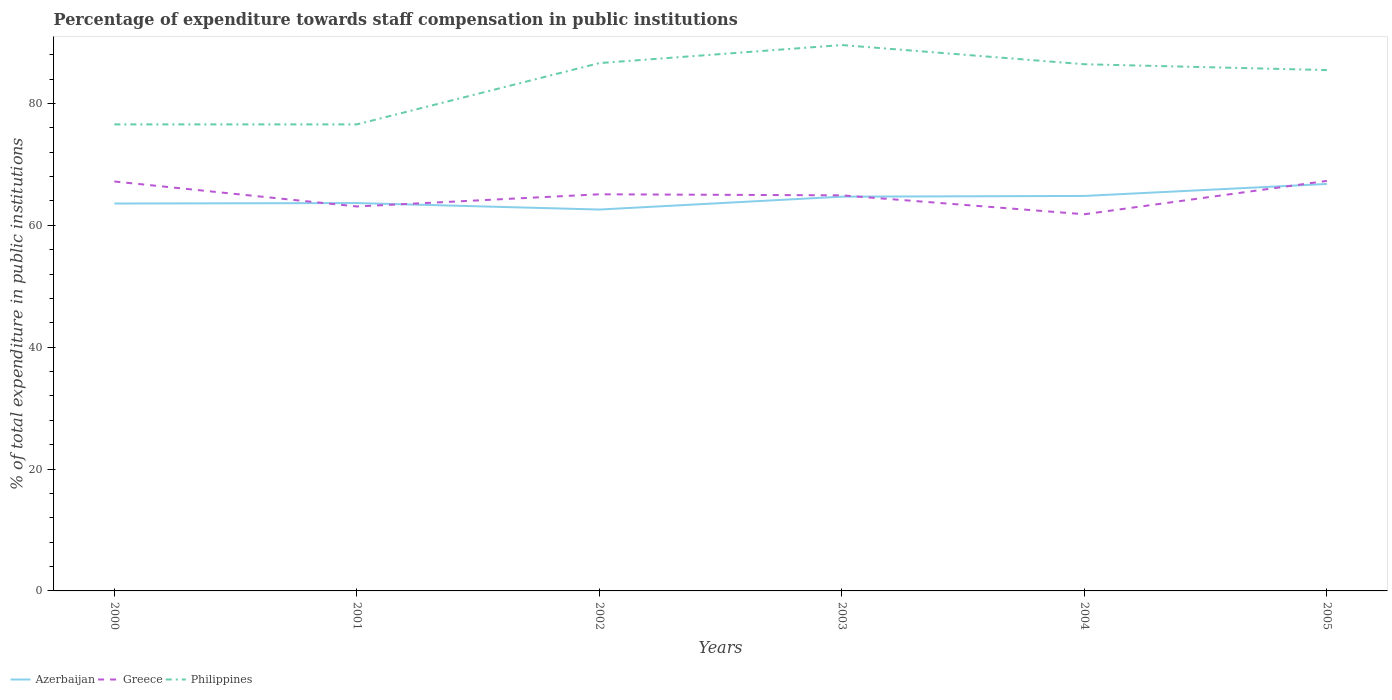Does the line corresponding to Azerbaijan intersect with the line corresponding to Philippines?
Your answer should be compact. No. Is the number of lines equal to the number of legend labels?
Your answer should be compact. Yes. Across all years, what is the maximum percentage of expenditure towards staff compensation in Greece?
Provide a short and direct response. 61.82. In which year was the percentage of expenditure towards staff compensation in Greece maximum?
Keep it short and to the point. 2004. What is the total percentage of expenditure towards staff compensation in Philippines in the graph?
Your answer should be compact. 1.14. What is the difference between the highest and the second highest percentage of expenditure towards staff compensation in Greece?
Keep it short and to the point. 5.48. Is the percentage of expenditure towards staff compensation in Greece strictly greater than the percentage of expenditure towards staff compensation in Azerbaijan over the years?
Your answer should be compact. No. How many lines are there?
Make the answer very short. 3. How many years are there in the graph?
Your answer should be very brief. 6. What is the difference between two consecutive major ticks on the Y-axis?
Provide a succinct answer. 20. Are the values on the major ticks of Y-axis written in scientific E-notation?
Make the answer very short. No. Does the graph contain grids?
Your answer should be compact. No. What is the title of the graph?
Provide a succinct answer. Percentage of expenditure towards staff compensation in public institutions. What is the label or title of the Y-axis?
Ensure brevity in your answer.  % of total expenditure in public institutions. What is the % of total expenditure in public institutions of Azerbaijan in 2000?
Your response must be concise. 63.58. What is the % of total expenditure in public institutions in Greece in 2000?
Give a very brief answer. 67.2. What is the % of total expenditure in public institutions in Philippines in 2000?
Your answer should be compact. 76.57. What is the % of total expenditure in public institutions of Azerbaijan in 2001?
Provide a short and direct response. 63.66. What is the % of total expenditure in public institutions in Greece in 2001?
Provide a succinct answer. 63.1. What is the % of total expenditure in public institutions of Philippines in 2001?
Offer a very short reply. 76.57. What is the % of total expenditure in public institutions of Azerbaijan in 2002?
Your response must be concise. 62.59. What is the % of total expenditure in public institutions of Greece in 2002?
Ensure brevity in your answer.  65.1. What is the % of total expenditure in public institutions of Philippines in 2002?
Your answer should be compact. 86.63. What is the % of total expenditure in public institutions of Azerbaijan in 2003?
Offer a terse response. 64.71. What is the % of total expenditure in public institutions in Greece in 2003?
Make the answer very short. 64.93. What is the % of total expenditure in public institutions in Philippines in 2003?
Offer a terse response. 89.59. What is the % of total expenditure in public institutions in Azerbaijan in 2004?
Provide a succinct answer. 64.83. What is the % of total expenditure in public institutions of Greece in 2004?
Provide a succinct answer. 61.82. What is the % of total expenditure in public institutions in Philippines in 2004?
Provide a short and direct response. 86.44. What is the % of total expenditure in public institutions in Azerbaijan in 2005?
Offer a very short reply. 66.79. What is the % of total expenditure in public institutions of Greece in 2005?
Offer a very short reply. 67.29. What is the % of total expenditure in public institutions of Philippines in 2005?
Your response must be concise. 85.49. Across all years, what is the maximum % of total expenditure in public institutions of Azerbaijan?
Provide a succinct answer. 66.79. Across all years, what is the maximum % of total expenditure in public institutions in Greece?
Offer a terse response. 67.29. Across all years, what is the maximum % of total expenditure in public institutions in Philippines?
Offer a very short reply. 89.59. Across all years, what is the minimum % of total expenditure in public institutions of Azerbaijan?
Your response must be concise. 62.59. Across all years, what is the minimum % of total expenditure in public institutions of Greece?
Ensure brevity in your answer.  61.82. Across all years, what is the minimum % of total expenditure in public institutions in Philippines?
Your answer should be compact. 76.57. What is the total % of total expenditure in public institutions of Azerbaijan in the graph?
Keep it short and to the point. 386.15. What is the total % of total expenditure in public institutions of Greece in the graph?
Provide a short and direct response. 389.43. What is the total % of total expenditure in public institutions in Philippines in the graph?
Offer a very short reply. 501.29. What is the difference between the % of total expenditure in public institutions in Azerbaijan in 2000 and that in 2001?
Your answer should be compact. -0.08. What is the difference between the % of total expenditure in public institutions in Greece in 2000 and that in 2001?
Make the answer very short. 4.1. What is the difference between the % of total expenditure in public institutions in Philippines in 2000 and that in 2001?
Offer a terse response. 0. What is the difference between the % of total expenditure in public institutions in Azerbaijan in 2000 and that in 2002?
Give a very brief answer. 0.99. What is the difference between the % of total expenditure in public institutions in Greece in 2000 and that in 2002?
Offer a very short reply. 2.1. What is the difference between the % of total expenditure in public institutions in Philippines in 2000 and that in 2002?
Your answer should be compact. -10.06. What is the difference between the % of total expenditure in public institutions in Azerbaijan in 2000 and that in 2003?
Provide a succinct answer. -1.13. What is the difference between the % of total expenditure in public institutions in Greece in 2000 and that in 2003?
Provide a succinct answer. 2.27. What is the difference between the % of total expenditure in public institutions of Philippines in 2000 and that in 2003?
Provide a short and direct response. -13.02. What is the difference between the % of total expenditure in public institutions in Azerbaijan in 2000 and that in 2004?
Make the answer very short. -1.24. What is the difference between the % of total expenditure in public institutions in Greece in 2000 and that in 2004?
Provide a succinct answer. 5.38. What is the difference between the % of total expenditure in public institutions in Philippines in 2000 and that in 2004?
Provide a short and direct response. -9.87. What is the difference between the % of total expenditure in public institutions in Azerbaijan in 2000 and that in 2005?
Your answer should be very brief. -3.21. What is the difference between the % of total expenditure in public institutions in Greece in 2000 and that in 2005?
Offer a terse response. -0.1. What is the difference between the % of total expenditure in public institutions in Philippines in 2000 and that in 2005?
Your response must be concise. -8.92. What is the difference between the % of total expenditure in public institutions of Azerbaijan in 2001 and that in 2002?
Make the answer very short. 1.06. What is the difference between the % of total expenditure in public institutions in Greece in 2001 and that in 2002?
Your answer should be very brief. -2. What is the difference between the % of total expenditure in public institutions in Philippines in 2001 and that in 2002?
Make the answer very short. -10.06. What is the difference between the % of total expenditure in public institutions in Azerbaijan in 2001 and that in 2003?
Offer a terse response. -1.05. What is the difference between the % of total expenditure in public institutions in Greece in 2001 and that in 2003?
Your answer should be very brief. -1.83. What is the difference between the % of total expenditure in public institutions of Philippines in 2001 and that in 2003?
Your response must be concise. -13.02. What is the difference between the % of total expenditure in public institutions of Azerbaijan in 2001 and that in 2004?
Provide a succinct answer. -1.17. What is the difference between the % of total expenditure in public institutions of Greece in 2001 and that in 2004?
Give a very brief answer. 1.28. What is the difference between the % of total expenditure in public institutions in Philippines in 2001 and that in 2004?
Your response must be concise. -9.87. What is the difference between the % of total expenditure in public institutions in Azerbaijan in 2001 and that in 2005?
Give a very brief answer. -3.13. What is the difference between the % of total expenditure in public institutions in Greece in 2001 and that in 2005?
Your answer should be compact. -4.2. What is the difference between the % of total expenditure in public institutions in Philippines in 2001 and that in 2005?
Your answer should be very brief. -8.92. What is the difference between the % of total expenditure in public institutions of Azerbaijan in 2002 and that in 2003?
Offer a terse response. -2.12. What is the difference between the % of total expenditure in public institutions of Greece in 2002 and that in 2003?
Ensure brevity in your answer.  0.17. What is the difference between the % of total expenditure in public institutions of Philippines in 2002 and that in 2003?
Provide a succinct answer. -2.96. What is the difference between the % of total expenditure in public institutions in Azerbaijan in 2002 and that in 2004?
Keep it short and to the point. -2.23. What is the difference between the % of total expenditure in public institutions in Greece in 2002 and that in 2004?
Keep it short and to the point. 3.28. What is the difference between the % of total expenditure in public institutions of Philippines in 2002 and that in 2004?
Your answer should be compact. 0.19. What is the difference between the % of total expenditure in public institutions in Azerbaijan in 2002 and that in 2005?
Your response must be concise. -4.2. What is the difference between the % of total expenditure in public institutions of Greece in 2002 and that in 2005?
Provide a succinct answer. -2.2. What is the difference between the % of total expenditure in public institutions in Philippines in 2002 and that in 2005?
Keep it short and to the point. 1.14. What is the difference between the % of total expenditure in public institutions of Azerbaijan in 2003 and that in 2004?
Offer a terse response. -0.12. What is the difference between the % of total expenditure in public institutions of Greece in 2003 and that in 2004?
Offer a terse response. 3.11. What is the difference between the % of total expenditure in public institutions in Philippines in 2003 and that in 2004?
Make the answer very short. 3.15. What is the difference between the % of total expenditure in public institutions of Azerbaijan in 2003 and that in 2005?
Your response must be concise. -2.08. What is the difference between the % of total expenditure in public institutions of Greece in 2003 and that in 2005?
Keep it short and to the point. -2.37. What is the difference between the % of total expenditure in public institutions in Philippines in 2003 and that in 2005?
Offer a terse response. 4.11. What is the difference between the % of total expenditure in public institutions of Azerbaijan in 2004 and that in 2005?
Your answer should be very brief. -1.97. What is the difference between the % of total expenditure in public institutions in Greece in 2004 and that in 2005?
Keep it short and to the point. -5.47. What is the difference between the % of total expenditure in public institutions of Philippines in 2004 and that in 2005?
Make the answer very short. 0.96. What is the difference between the % of total expenditure in public institutions in Azerbaijan in 2000 and the % of total expenditure in public institutions in Greece in 2001?
Your answer should be very brief. 0.48. What is the difference between the % of total expenditure in public institutions in Azerbaijan in 2000 and the % of total expenditure in public institutions in Philippines in 2001?
Your response must be concise. -12.99. What is the difference between the % of total expenditure in public institutions of Greece in 2000 and the % of total expenditure in public institutions of Philippines in 2001?
Offer a very short reply. -9.37. What is the difference between the % of total expenditure in public institutions in Azerbaijan in 2000 and the % of total expenditure in public institutions in Greece in 2002?
Your response must be concise. -1.51. What is the difference between the % of total expenditure in public institutions in Azerbaijan in 2000 and the % of total expenditure in public institutions in Philippines in 2002?
Keep it short and to the point. -23.05. What is the difference between the % of total expenditure in public institutions of Greece in 2000 and the % of total expenditure in public institutions of Philippines in 2002?
Your answer should be compact. -19.43. What is the difference between the % of total expenditure in public institutions in Azerbaijan in 2000 and the % of total expenditure in public institutions in Greece in 2003?
Make the answer very short. -1.34. What is the difference between the % of total expenditure in public institutions in Azerbaijan in 2000 and the % of total expenditure in public institutions in Philippines in 2003?
Your response must be concise. -26.01. What is the difference between the % of total expenditure in public institutions of Greece in 2000 and the % of total expenditure in public institutions of Philippines in 2003?
Offer a terse response. -22.39. What is the difference between the % of total expenditure in public institutions of Azerbaijan in 2000 and the % of total expenditure in public institutions of Greece in 2004?
Offer a very short reply. 1.76. What is the difference between the % of total expenditure in public institutions of Azerbaijan in 2000 and the % of total expenditure in public institutions of Philippines in 2004?
Offer a terse response. -22.86. What is the difference between the % of total expenditure in public institutions in Greece in 2000 and the % of total expenditure in public institutions in Philippines in 2004?
Make the answer very short. -19.24. What is the difference between the % of total expenditure in public institutions of Azerbaijan in 2000 and the % of total expenditure in public institutions of Greece in 2005?
Ensure brevity in your answer.  -3.71. What is the difference between the % of total expenditure in public institutions in Azerbaijan in 2000 and the % of total expenditure in public institutions in Philippines in 2005?
Offer a very short reply. -21.9. What is the difference between the % of total expenditure in public institutions in Greece in 2000 and the % of total expenditure in public institutions in Philippines in 2005?
Your answer should be compact. -18.29. What is the difference between the % of total expenditure in public institutions of Azerbaijan in 2001 and the % of total expenditure in public institutions of Greece in 2002?
Your answer should be very brief. -1.44. What is the difference between the % of total expenditure in public institutions of Azerbaijan in 2001 and the % of total expenditure in public institutions of Philippines in 2002?
Ensure brevity in your answer.  -22.97. What is the difference between the % of total expenditure in public institutions in Greece in 2001 and the % of total expenditure in public institutions in Philippines in 2002?
Make the answer very short. -23.53. What is the difference between the % of total expenditure in public institutions in Azerbaijan in 2001 and the % of total expenditure in public institutions in Greece in 2003?
Provide a short and direct response. -1.27. What is the difference between the % of total expenditure in public institutions of Azerbaijan in 2001 and the % of total expenditure in public institutions of Philippines in 2003?
Your response must be concise. -25.94. What is the difference between the % of total expenditure in public institutions in Greece in 2001 and the % of total expenditure in public institutions in Philippines in 2003?
Offer a very short reply. -26.49. What is the difference between the % of total expenditure in public institutions in Azerbaijan in 2001 and the % of total expenditure in public institutions in Greece in 2004?
Keep it short and to the point. 1.84. What is the difference between the % of total expenditure in public institutions of Azerbaijan in 2001 and the % of total expenditure in public institutions of Philippines in 2004?
Your answer should be compact. -22.78. What is the difference between the % of total expenditure in public institutions in Greece in 2001 and the % of total expenditure in public institutions in Philippines in 2004?
Provide a succinct answer. -23.34. What is the difference between the % of total expenditure in public institutions of Azerbaijan in 2001 and the % of total expenditure in public institutions of Greece in 2005?
Keep it short and to the point. -3.64. What is the difference between the % of total expenditure in public institutions in Azerbaijan in 2001 and the % of total expenditure in public institutions in Philippines in 2005?
Make the answer very short. -21.83. What is the difference between the % of total expenditure in public institutions of Greece in 2001 and the % of total expenditure in public institutions of Philippines in 2005?
Make the answer very short. -22.39. What is the difference between the % of total expenditure in public institutions of Azerbaijan in 2002 and the % of total expenditure in public institutions of Greece in 2003?
Offer a terse response. -2.33. What is the difference between the % of total expenditure in public institutions in Azerbaijan in 2002 and the % of total expenditure in public institutions in Philippines in 2003?
Offer a very short reply. -27. What is the difference between the % of total expenditure in public institutions of Greece in 2002 and the % of total expenditure in public institutions of Philippines in 2003?
Your answer should be compact. -24.5. What is the difference between the % of total expenditure in public institutions of Azerbaijan in 2002 and the % of total expenditure in public institutions of Greece in 2004?
Keep it short and to the point. 0.77. What is the difference between the % of total expenditure in public institutions in Azerbaijan in 2002 and the % of total expenditure in public institutions in Philippines in 2004?
Provide a succinct answer. -23.85. What is the difference between the % of total expenditure in public institutions in Greece in 2002 and the % of total expenditure in public institutions in Philippines in 2004?
Keep it short and to the point. -21.34. What is the difference between the % of total expenditure in public institutions in Azerbaijan in 2002 and the % of total expenditure in public institutions in Greece in 2005?
Your response must be concise. -4.7. What is the difference between the % of total expenditure in public institutions in Azerbaijan in 2002 and the % of total expenditure in public institutions in Philippines in 2005?
Your answer should be very brief. -22.89. What is the difference between the % of total expenditure in public institutions of Greece in 2002 and the % of total expenditure in public institutions of Philippines in 2005?
Your answer should be very brief. -20.39. What is the difference between the % of total expenditure in public institutions in Azerbaijan in 2003 and the % of total expenditure in public institutions in Greece in 2004?
Give a very brief answer. 2.89. What is the difference between the % of total expenditure in public institutions of Azerbaijan in 2003 and the % of total expenditure in public institutions of Philippines in 2004?
Keep it short and to the point. -21.73. What is the difference between the % of total expenditure in public institutions of Greece in 2003 and the % of total expenditure in public institutions of Philippines in 2004?
Provide a succinct answer. -21.52. What is the difference between the % of total expenditure in public institutions of Azerbaijan in 2003 and the % of total expenditure in public institutions of Greece in 2005?
Keep it short and to the point. -2.59. What is the difference between the % of total expenditure in public institutions in Azerbaijan in 2003 and the % of total expenditure in public institutions in Philippines in 2005?
Provide a short and direct response. -20.78. What is the difference between the % of total expenditure in public institutions in Greece in 2003 and the % of total expenditure in public institutions in Philippines in 2005?
Keep it short and to the point. -20.56. What is the difference between the % of total expenditure in public institutions of Azerbaijan in 2004 and the % of total expenditure in public institutions of Greece in 2005?
Your answer should be compact. -2.47. What is the difference between the % of total expenditure in public institutions of Azerbaijan in 2004 and the % of total expenditure in public institutions of Philippines in 2005?
Your answer should be compact. -20.66. What is the difference between the % of total expenditure in public institutions of Greece in 2004 and the % of total expenditure in public institutions of Philippines in 2005?
Your response must be concise. -23.67. What is the average % of total expenditure in public institutions in Azerbaijan per year?
Offer a terse response. 64.36. What is the average % of total expenditure in public institutions in Greece per year?
Make the answer very short. 64.91. What is the average % of total expenditure in public institutions of Philippines per year?
Your answer should be very brief. 83.55. In the year 2000, what is the difference between the % of total expenditure in public institutions in Azerbaijan and % of total expenditure in public institutions in Greece?
Provide a short and direct response. -3.62. In the year 2000, what is the difference between the % of total expenditure in public institutions of Azerbaijan and % of total expenditure in public institutions of Philippines?
Offer a terse response. -12.99. In the year 2000, what is the difference between the % of total expenditure in public institutions of Greece and % of total expenditure in public institutions of Philippines?
Make the answer very short. -9.37. In the year 2001, what is the difference between the % of total expenditure in public institutions in Azerbaijan and % of total expenditure in public institutions in Greece?
Offer a very short reply. 0.56. In the year 2001, what is the difference between the % of total expenditure in public institutions of Azerbaijan and % of total expenditure in public institutions of Philippines?
Your response must be concise. -12.91. In the year 2001, what is the difference between the % of total expenditure in public institutions of Greece and % of total expenditure in public institutions of Philippines?
Give a very brief answer. -13.47. In the year 2002, what is the difference between the % of total expenditure in public institutions of Azerbaijan and % of total expenditure in public institutions of Greece?
Your answer should be very brief. -2.5. In the year 2002, what is the difference between the % of total expenditure in public institutions of Azerbaijan and % of total expenditure in public institutions of Philippines?
Your answer should be compact. -24.04. In the year 2002, what is the difference between the % of total expenditure in public institutions in Greece and % of total expenditure in public institutions in Philippines?
Keep it short and to the point. -21.53. In the year 2003, what is the difference between the % of total expenditure in public institutions in Azerbaijan and % of total expenditure in public institutions in Greece?
Ensure brevity in your answer.  -0.22. In the year 2003, what is the difference between the % of total expenditure in public institutions of Azerbaijan and % of total expenditure in public institutions of Philippines?
Ensure brevity in your answer.  -24.88. In the year 2003, what is the difference between the % of total expenditure in public institutions of Greece and % of total expenditure in public institutions of Philippines?
Your answer should be compact. -24.67. In the year 2004, what is the difference between the % of total expenditure in public institutions of Azerbaijan and % of total expenditure in public institutions of Greece?
Provide a succinct answer. 3.01. In the year 2004, what is the difference between the % of total expenditure in public institutions in Azerbaijan and % of total expenditure in public institutions in Philippines?
Your answer should be compact. -21.62. In the year 2004, what is the difference between the % of total expenditure in public institutions in Greece and % of total expenditure in public institutions in Philippines?
Provide a succinct answer. -24.62. In the year 2005, what is the difference between the % of total expenditure in public institutions of Azerbaijan and % of total expenditure in public institutions of Greece?
Offer a very short reply. -0.5. In the year 2005, what is the difference between the % of total expenditure in public institutions in Azerbaijan and % of total expenditure in public institutions in Philippines?
Your response must be concise. -18.69. In the year 2005, what is the difference between the % of total expenditure in public institutions in Greece and % of total expenditure in public institutions in Philippines?
Your response must be concise. -18.19. What is the ratio of the % of total expenditure in public institutions in Azerbaijan in 2000 to that in 2001?
Offer a very short reply. 1. What is the ratio of the % of total expenditure in public institutions in Greece in 2000 to that in 2001?
Your answer should be compact. 1.06. What is the ratio of the % of total expenditure in public institutions of Azerbaijan in 2000 to that in 2002?
Your response must be concise. 1.02. What is the ratio of the % of total expenditure in public institutions of Greece in 2000 to that in 2002?
Offer a terse response. 1.03. What is the ratio of the % of total expenditure in public institutions in Philippines in 2000 to that in 2002?
Ensure brevity in your answer.  0.88. What is the ratio of the % of total expenditure in public institutions of Azerbaijan in 2000 to that in 2003?
Offer a very short reply. 0.98. What is the ratio of the % of total expenditure in public institutions of Greece in 2000 to that in 2003?
Your answer should be very brief. 1.03. What is the ratio of the % of total expenditure in public institutions of Philippines in 2000 to that in 2003?
Keep it short and to the point. 0.85. What is the ratio of the % of total expenditure in public institutions in Azerbaijan in 2000 to that in 2004?
Ensure brevity in your answer.  0.98. What is the ratio of the % of total expenditure in public institutions of Greece in 2000 to that in 2004?
Give a very brief answer. 1.09. What is the ratio of the % of total expenditure in public institutions in Philippines in 2000 to that in 2004?
Offer a terse response. 0.89. What is the ratio of the % of total expenditure in public institutions in Azerbaijan in 2000 to that in 2005?
Your response must be concise. 0.95. What is the ratio of the % of total expenditure in public institutions in Greece in 2000 to that in 2005?
Your answer should be compact. 1. What is the ratio of the % of total expenditure in public institutions of Philippines in 2000 to that in 2005?
Give a very brief answer. 0.9. What is the ratio of the % of total expenditure in public institutions in Greece in 2001 to that in 2002?
Your response must be concise. 0.97. What is the ratio of the % of total expenditure in public institutions of Philippines in 2001 to that in 2002?
Make the answer very short. 0.88. What is the ratio of the % of total expenditure in public institutions of Azerbaijan in 2001 to that in 2003?
Give a very brief answer. 0.98. What is the ratio of the % of total expenditure in public institutions in Greece in 2001 to that in 2003?
Provide a succinct answer. 0.97. What is the ratio of the % of total expenditure in public institutions of Philippines in 2001 to that in 2003?
Give a very brief answer. 0.85. What is the ratio of the % of total expenditure in public institutions in Greece in 2001 to that in 2004?
Offer a terse response. 1.02. What is the ratio of the % of total expenditure in public institutions of Philippines in 2001 to that in 2004?
Give a very brief answer. 0.89. What is the ratio of the % of total expenditure in public institutions in Azerbaijan in 2001 to that in 2005?
Your answer should be very brief. 0.95. What is the ratio of the % of total expenditure in public institutions of Greece in 2001 to that in 2005?
Your answer should be compact. 0.94. What is the ratio of the % of total expenditure in public institutions in Philippines in 2001 to that in 2005?
Your answer should be compact. 0.9. What is the ratio of the % of total expenditure in public institutions of Azerbaijan in 2002 to that in 2003?
Give a very brief answer. 0.97. What is the ratio of the % of total expenditure in public institutions of Philippines in 2002 to that in 2003?
Your answer should be compact. 0.97. What is the ratio of the % of total expenditure in public institutions of Azerbaijan in 2002 to that in 2004?
Offer a very short reply. 0.97. What is the ratio of the % of total expenditure in public institutions in Greece in 2002 to that in 2004?
Keep it short and to the point. 1.05. What is the ratio of the % of total expenditure in public institutions of Philippines in 2002 to that in 2004?
Make the answer very short. 1. What is the ratio of the % of total expenditure in public institutions of Azerbaijan in 2002 to that in 2005?
Offer a terse response. 0.94. What is the ratio of the % of total expenditure in public institutions of Greece in 2002 to that in 2005?
Your answer should be compact. 0.97. What is the ratio of the % of total expenditure in public institutions of Philippines in 2002 to that in 2005?
Give a very brief answer. 1.01. What is the ratio of the % of total expenditure in public institutions in Greece in 2003 to that in 2004?
Keep it short and to the point. 1.05. What is the ratio of the % of total expenditure in public institutions of Philippines in 2003 to that in 2004?
Your response must be concise. 1.04. What is the ratio of the % of total expenditure in public institutions in Azerbaijan in 2003 to that in 2005?
Your response must be concise. 0.97. What is the ratio of the % of total expenditure in public institutions in Greece in 2003 to that in 2005?
Your answer should be compact. 0.96. What is the ratio of the % of total expenditure in public institutions of Philippines in 2003 to that in 2005?
Your answer should be very brief. 1.05. What is the ratio of the % of total expenditure in public institutions in Azerbaijan in 2004 to that in 2005?
Offer a terse response. 0.97. What is the ratio of the % of total expenditure in public institutions of Greece in 2004 to that in 2005?
Offer a terse response. 0.92. What is the ratio of the % of total expenditure in public institutions of Philippines in 2004 to that in 2005?
Keep it short and to the point. 1.01. What is the difference between the highest and the second highest % of total expenditure in public institutions of Azerbaijan?
Provide a short and direct response. 1.97. What is the difference between the highest and the second highest % of total expenditure in public institutions of Greece?
Offer a terse response. 0.1. What is the difference between the highest and the second highest % of total expenditure in public institutions of Philippines?
Provide a short and direct response. 2.96. What is the difference between the highest and the lowest % of total expenditure in public institutions of Azerbaijan?
Provide a short and direct response. 4.2. What is the difference between the highest and the lowest % of total expenditure in public institutions in Greece?
Your answer should be very brief. 5.47. What is the difference between the highest and the lowest % of total expenditure in public institutions of Philippines?
Offer a very short reply. 13.02. 